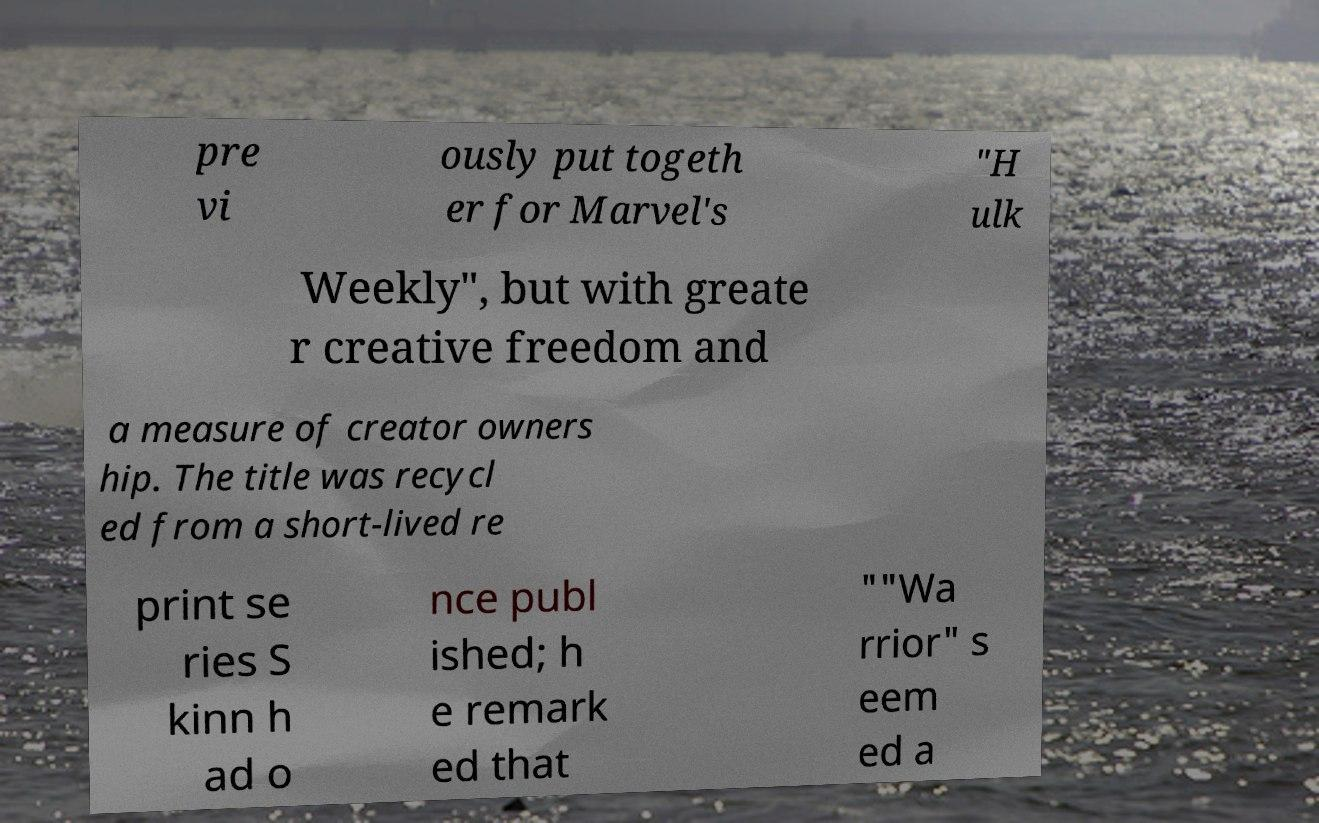Please identify and transcribe the text found in this image. pre vi ously put togeth er for Marvel's "H ulk Weekly", but with greate r creative freedom and a measure of creator owners hip. The title was recycl ed from a short-lived re print se ries S kinn h ad o nce publ ished; h e remark ed that ""Wa rrior" s eem ed a 